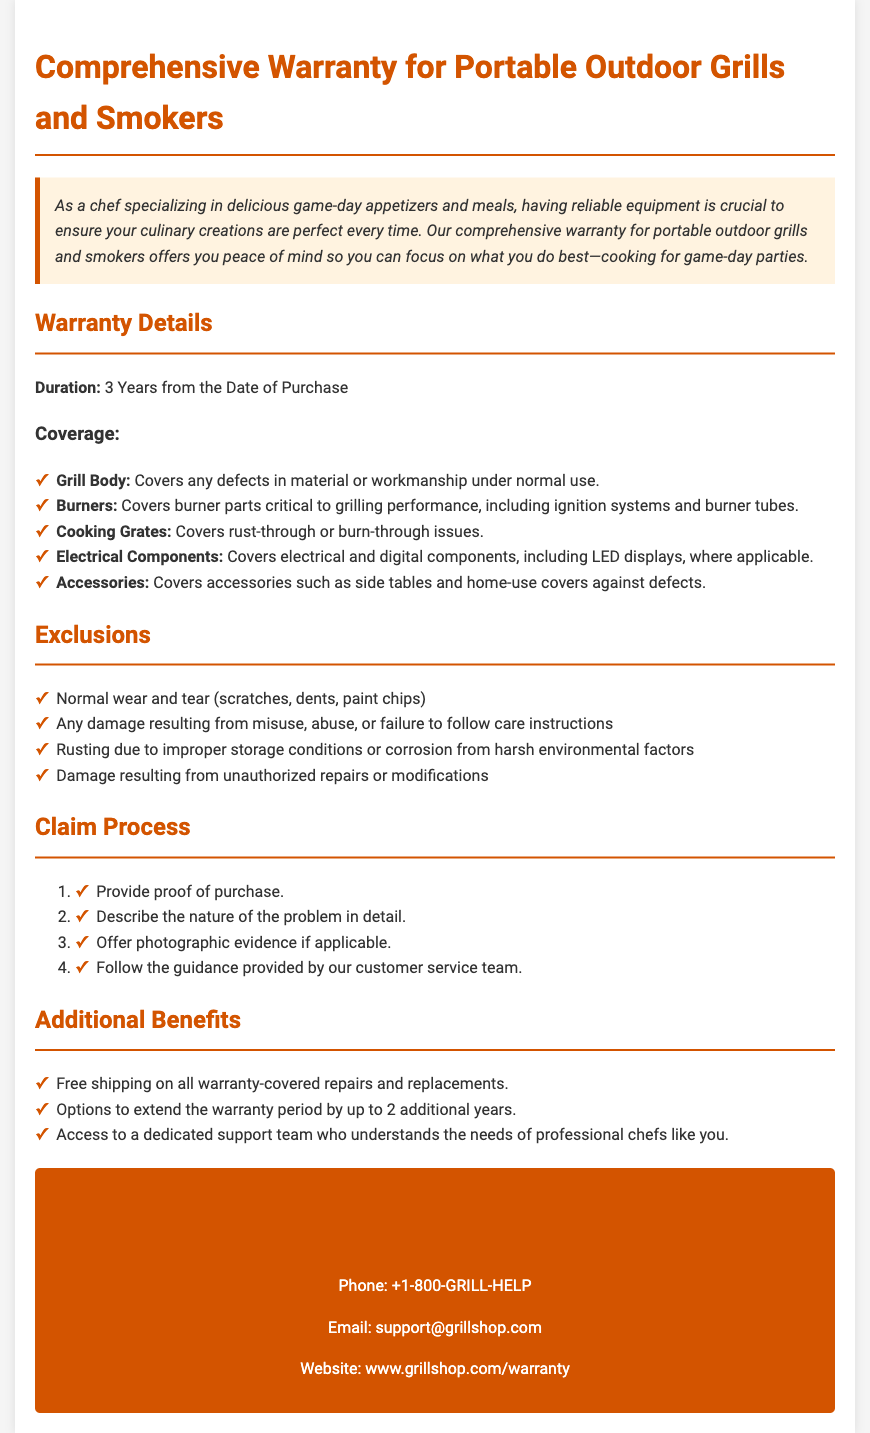What is the duration of the warranty? The duration of the warranty is specified in the document as 3 years from the date of purchase.
Answer: 3 Years What components are covered under the warranty? The document lists specific components that are covered, such as the grill body, burners, cooking grates, and electrical components.
Answer: Grill Body, Burners, Cooking Grates, Electrical Components, Accessories What is excluded from the warranty? The document outlines exclusions, including normal wear and tear, misuse, and unauthorized repairs.
Answer: Normal wear and tear, misuse, unauthorized repairs What is the first step in the claim process? The claim process requires starting with providing proof of purchase, as stated in the document.
Answer: Provide proof of purchase How many additional years can the warranty be extended? The document mentions options to extend the warranty period by up to 2 additional years.
Answer: 2 additional years What type of support does the warranty offer? The document describes dedicated support for professional chefs, indicating that it is tailored to their needs.
Answer: Dedicated support team What is the contact phone number for warranty claims? The document provides a contact phone number for warranty claims and support.
Answer: +1-800-GRILL-HELP What is covered under accessories? Accessories are listed in the warranty coverage, covering defects associated with items like side tables.
Answer: Defects in accessories like side tables What should be provided if applicable during the claim process? The claim process includes offering photographic evidence if applicable, as noted in the document.
Answer: Photographic evidence 